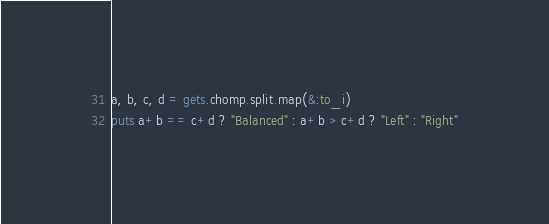<code> <loc_0><loc_0><loc_500><loc_500><_Ruby_>a, b, c, d = gets.chomp.split.map(&:to_i)
puts a+b == c+d ? "Balanced" : a+b > c+d ? "Left" : "Right"</code> 